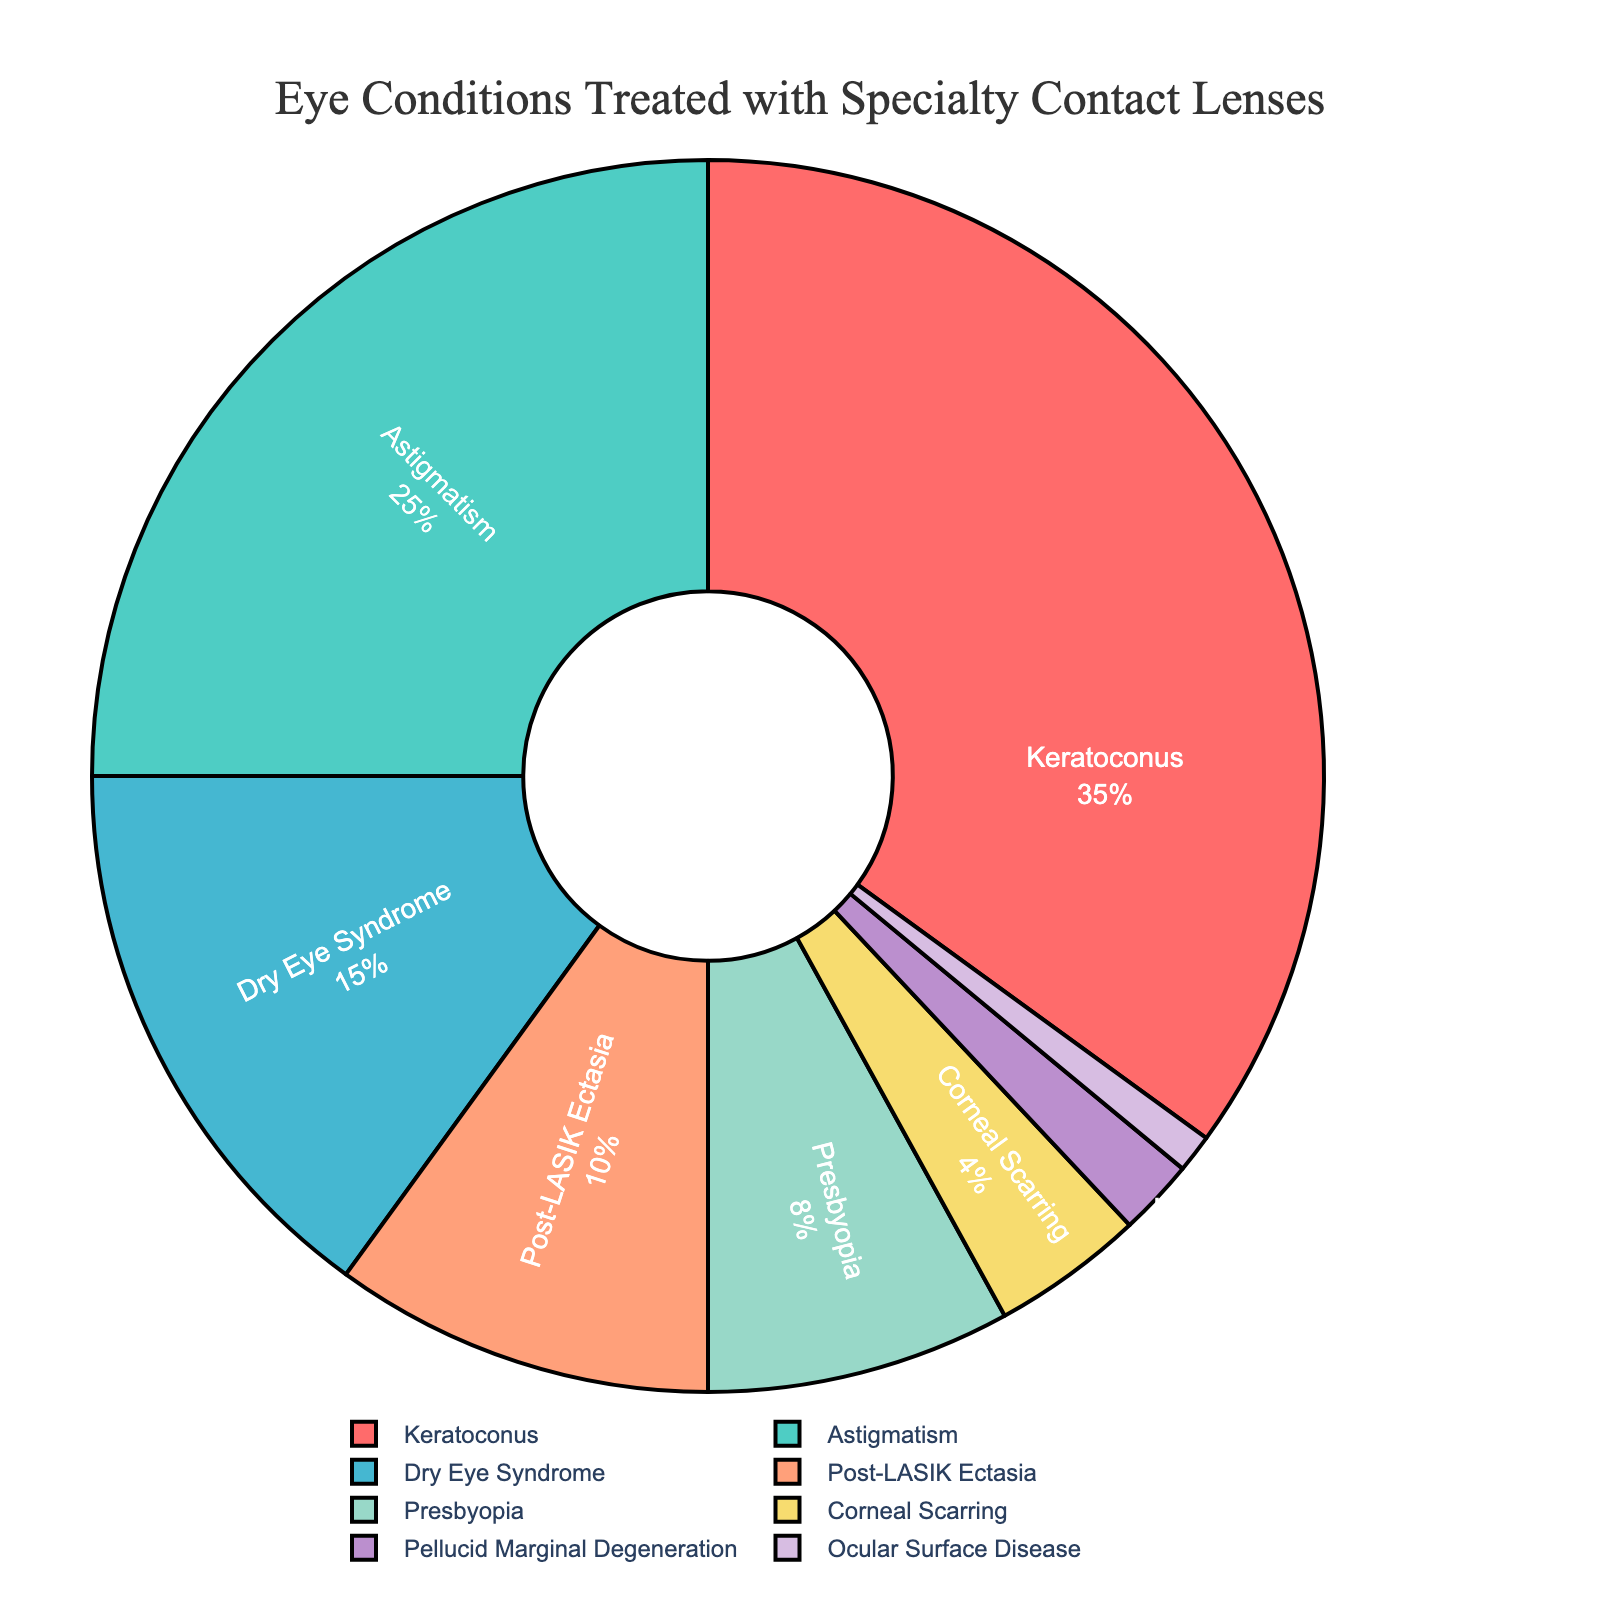What percentage of the treated eye conditions does Keratoconus represent? The pie chart shows the percentage breakdown where Keratoconus represents 35%. This can be directly noted from the section labeled "Keratoconus."
Answer: 35% Which eye condition has the second highest percentage and what is its value? From the pie chart, the condition with the second highest percentage is Astigmatism, which represents 25%. This can be directly noted from the label "Astigmatism" and its corresponding percentage value.
Answer: Astigmatism, 25% What is the total percentage of eye conditions treated that fall under Keratoconus, Astigmatism, and Dry Eye Syndrome combined? By adding the percentages of Keratoconus (35%), Astigmatism (25%), and Dry Eye Syndrome (15%) together, we get 35 + 25 + 15 = 75%.
Answer: 75% Which conditions collectively make up less than 10% of the treated eye conditions? By examining the pie chart, the conditions that collectively sum up to less than 10% are Ocular Surface Disease (1%) and Pellucid Marginal Degeneration (2%). Adding them gives 1 + 2 = 3%, which is less than 10%. There is also Corneal Scarring (4%) included in the list, making the total 1 + 2 + 4 = 7%.
Answer: Ocular Surface Disease, Pellucid Marginal Degeneration, Corneal Scarring How much larger is the percentage of Keratoconus compared to Post-LASIK Ectasia? The percentage for Keratoconus is 35% and for Post-LASIK Ectasia is 10%. The difference is calculated as 35 - 10 = 25%.
Answer: 25% Which eye condition has the smallest representation, and what is the percentage? The smallest represented eye condition on the pie chart is Ocular Surface Disease, which is labeled as 1%. This can be directly observed from the chart.
Answer: Ocular Surface Disease, 1% What is the combined percentage of eye conditions that each individually make up more than 10%? The eye conditions that individually make up more than 10% are Keratoconus (35%), Astigmatism (25%), and Dry Eye Syndrome (15%). Adding them together gives 35 + 25 + 15 = 75%.
Answer: 75% How does the percentage of conditions treated for Dry Eye Syndrome compare to Presbyopia? Dry Eye Syndrome accounts for 15% while Presbyopia accounts for 8%. Comparing these, Dry Eye Syndrome has a higher percentage.
Answer: Dry Eye Syndrome is higher What is the color representing Corneal Scarring on the pie chart? Corneal Scarring is represented with the color yellow on the pie chart, as observed from the visual color coding.
Answer: Yellow Is the percentage of patients treated for Post-LASIK Ectasia equal to the combined percentage for Presbyopia and Pellucid Marginal Degeneration? Post-LASIK Ectasia is 10%. Adding Presbyopia (8%) and Pellucid Marginal Degeneration (2%) gives 8 + 2 = 10%, which is equal.
Answer: Yes, they are equal 